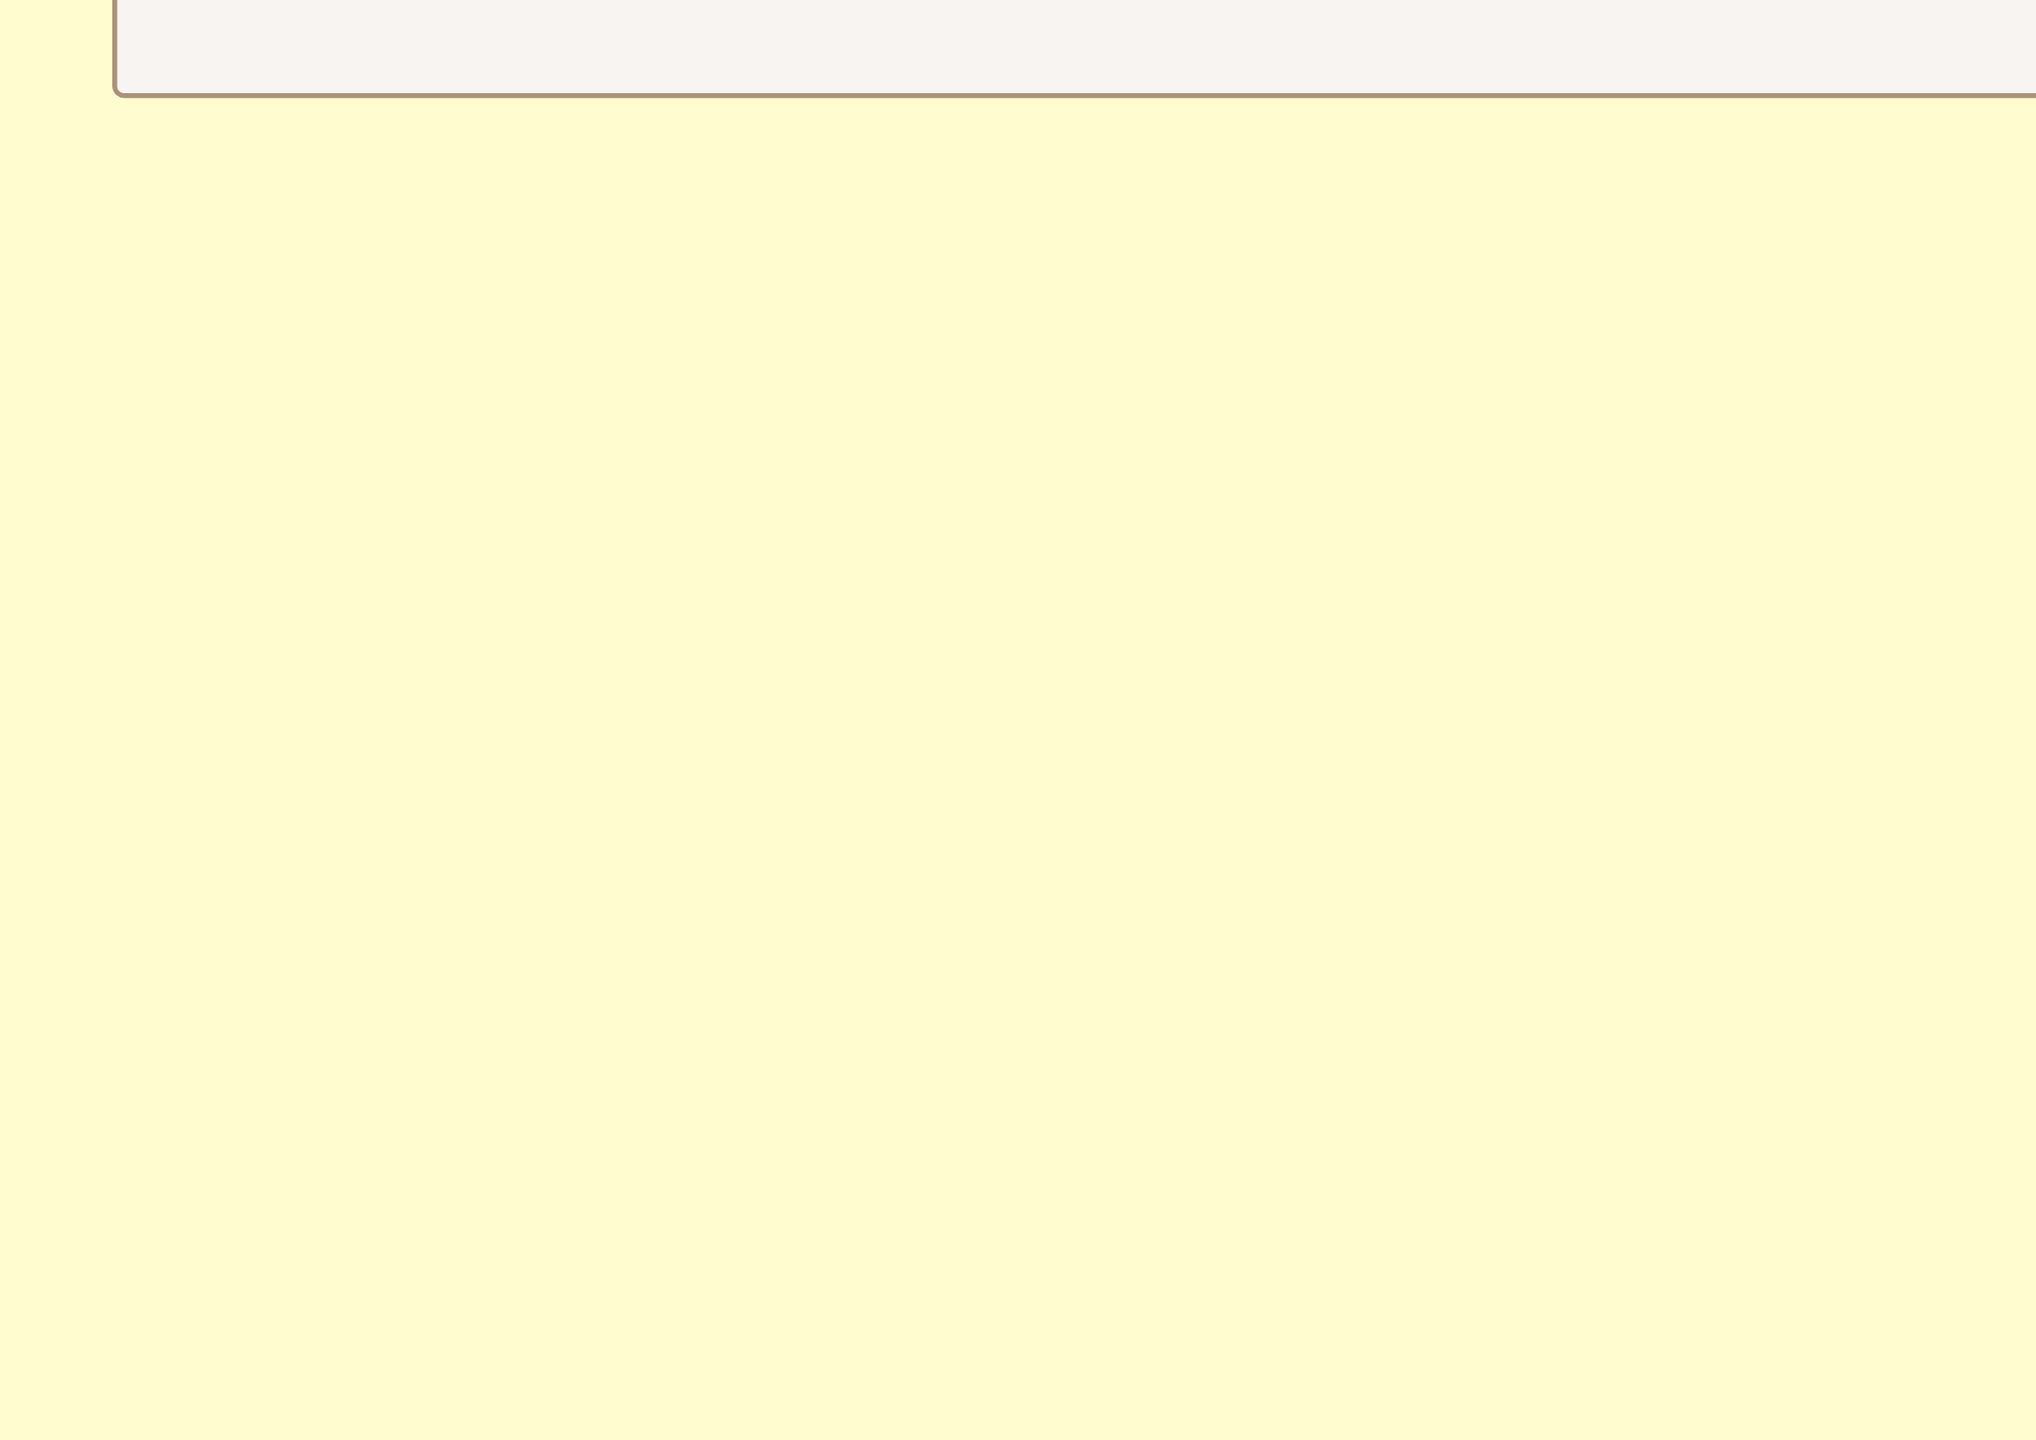What is the total cost of the vintage-style fabric loom? The total cost for the vintage-style fabric loom is provided in the capital expenditures section of the document.
Answer: 150,000 How much capital is allocated to the warehouse expansion? The document specifies the total cost allocated for the warehouse expansion under capital expenditures.
Answer: 500,000 What is the estimated revenue from the 1950s American car interiors? The document lists the estimated revenue for each product line, including the 1950s American car interiors.
Answer: 350,000 What percentage increase in production capacity is targeted? The production expansion goals indicate the targeted percentage increase in production capacity.
Answer: 30% What is the estimated cost for raw materials? The operational expenses section provides the estimated cost allocation for raw materials.
Answer: 200,000 How much will be spent on training? The document specifies the estimated cost for training under operational expenses.
Answer: 25,000 What is the interest rate for the bank loan? The financing options section of the document states the interest rate for the bank loan.
Answer: 5.5% What are the key performance indicators mentioned? The document lists multiple key performance indicators for assessing the financial plan.
Answer: Production volume increase, Revenue growth, Return on investment, Customer satisfaction rating How many industrial sewing machines are included in the plan? The capital expenditures section specifies the number of industrial sewing machines planned for purchase.
Answer: 5 What is the total estimated cost for labor? The operational expenses section lists the total estimated cost for labor.
Answer: 180,000 